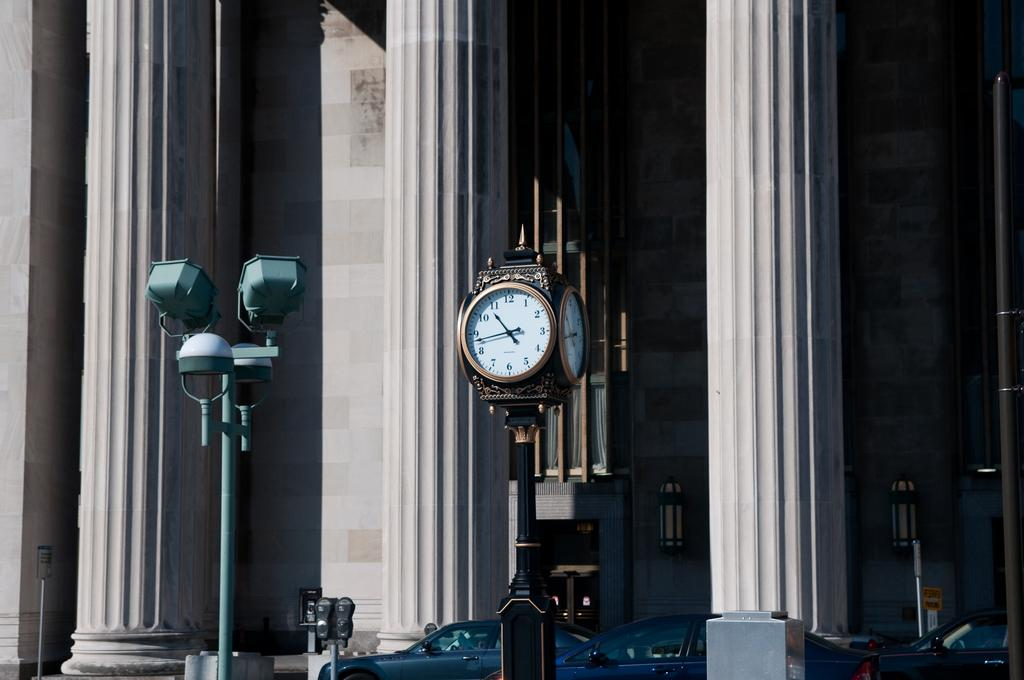<image>
Relay a brief, clear account of the picture shown. A large outdoor clock with the numbers 1-12 on its face 